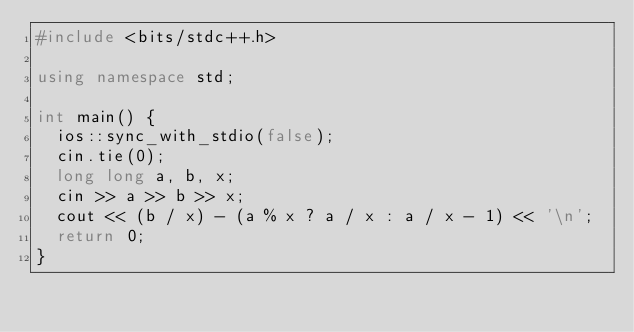Convert code to text. <code><loc_0><loc_0><loc_500><loc_500><_C++_>#include <bits/stdc++.h>

using namespace std;

int main() {
  ios::sync_with_stdio(false);
  cin.tie(0);
  long long a, b, x;
  cin >> a >> b >> x;
  cout << (b / x) - (a % x ? a / x : a / x - 1) << '\n';
  return 0;
}
</code> 